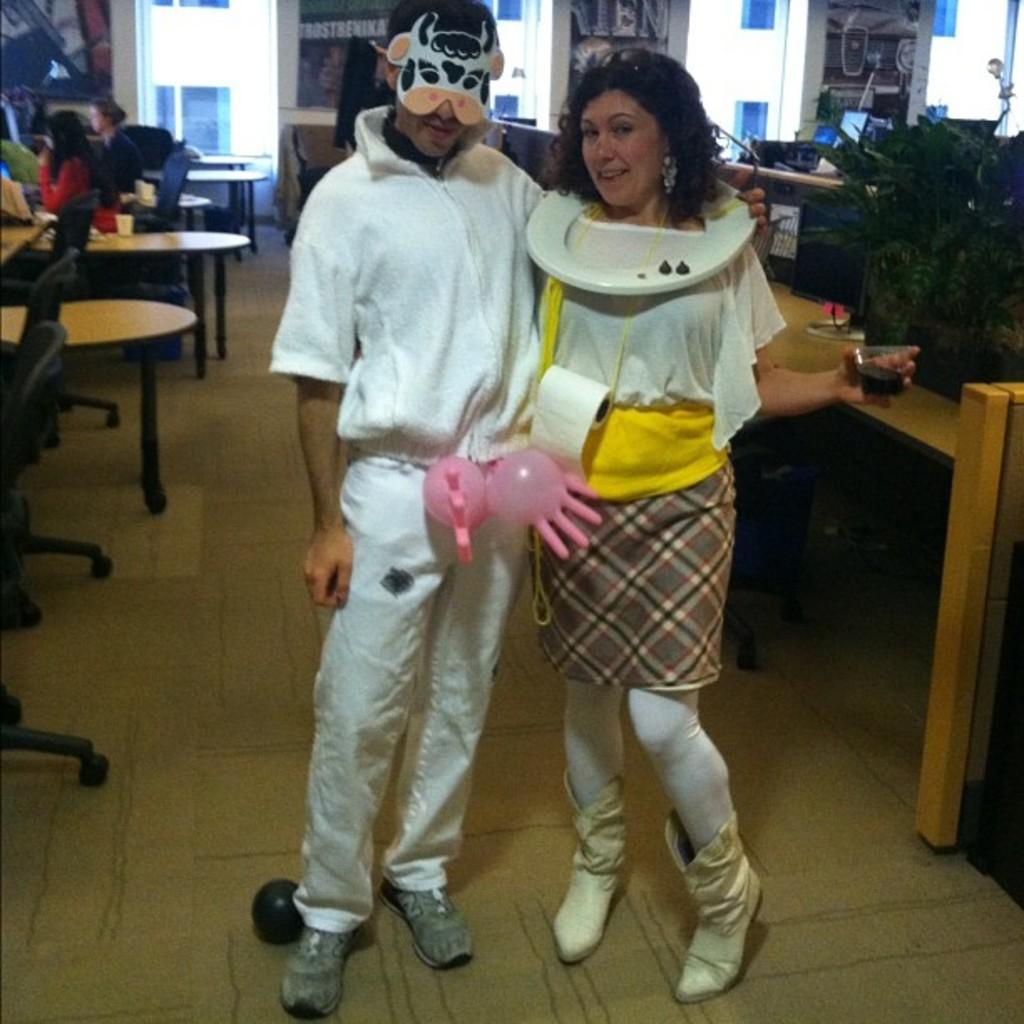How many people are present in the image? There are two people standing in the image. What can be seen in the background of the image? There are tables and people sitting on chairs in the background of the image. What type of books can be seen on the drum in the image? There are no books or drums present in the image. 